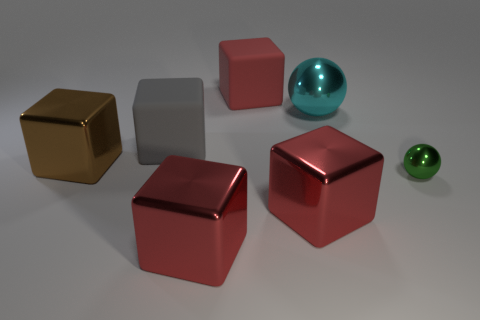Are there any metal cubes behind the shiny thing that is on the right side of the cyan ball that is left of the tiny green sphere?
Offer a very short reply. Yes. There is a gray object that is the same size as the cyan sphere; what is its shape?
Offer a terse response. Cube. What number of other things are the same color as the tiny object?
Provide a succinct answer. 0. What is the cyan object made of?
Make the answer very short. Metal. How many other objects are there of the same material as the brown cube?
Give a very brief answer. 4. There is a shiny object that is on the left side of the big red rubber block and in front of the large brown metal object; what is its size?
Your answer should be very brief. Large. What is the shape of the big red thing that is behind the metal block that is behind the tiny green sphere?
Keep it short and to the point. Cube. Is there any other thing that is the same shape as the large cyan thing?
Provide a short and direct response. Yes. Are there an equal number of small spheres that are behind the big brown metallic cube and red matte cylinders?
Keep it short and to the point. Yes. There is a tiny metal sphere; does it have the same color as the metal ball behind the brown cube?
Give a very brief answer. No. 